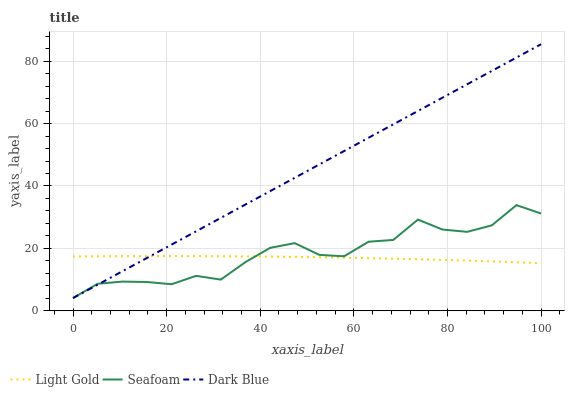Does Seafoam have the minimum area under the curve?
Answer yes or no. No. Does Seafoam have the maximum area under the curve?
Answer yes or no. No. Is Light Gold the smoothest?
Answer yes or no. No. Is Light Gold the roughest?
Answer yes or no. No. Does Light Gold have the lowest value?
Answer yes or no. No. Does Seafoam have the highest value?
Answer yes or no. No. 